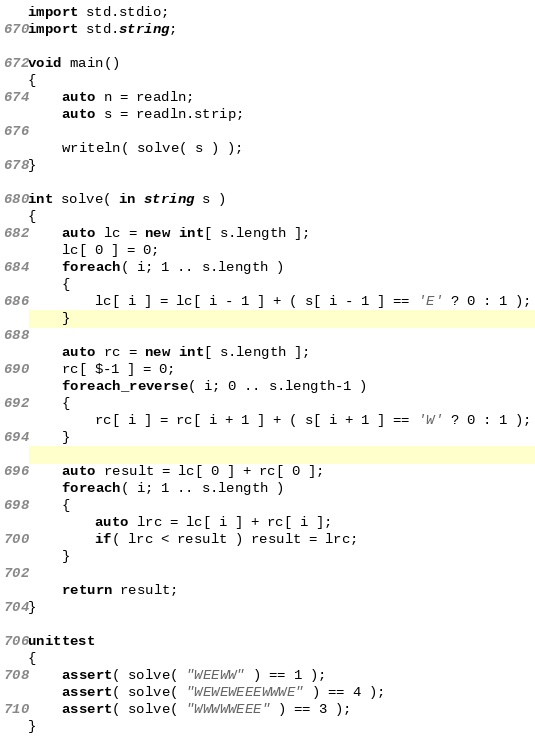<code> <loc_0><loc_0><loc_500><loc_500><_D_>
import std.stdio;
import std.string;

void main()
{
	auto n = readln;
	auto s = readln.strip;
	
	writeln( solve( s ) );
}

int solve( in string s )
{
	auto lc = new int[ s.length ];
	lc[ 0 ] = 0;
	foreach( i; 1 .. s.length )
	{
		lc[ i ] = lc[ i - 1 ] + ( s[ i - 1 ] == 'E' ? 0 : 1 );
	}
	
	auto rc = new int[ s.length ];
	rc[ $-1 ] = 0;
	foreach_reverse( i; 0 .. s.length-1 )
	{
		rc[ i ] = rc[ i + 1 ] + ( s[ i + 1 ] == 'W' ? 0 : 1 );
	}
	
	auto result = lc[ 0 ] + rc[ 0 ];
	foreach( i; 1 .. s.length )
	{
		auto lrc = lc[ i ] + rc[ i ];
		if( lrc < result ) result = lrc;
	}
	
	return result;
}

unittest
{
	assert( solve( "WEEWW" ) == 1 );
	assert( solve( "WEWEWEEEWWWE" ) == 4 );
	assert( solve( "WWWWWEEE" ) == 3 );
}
</code> 